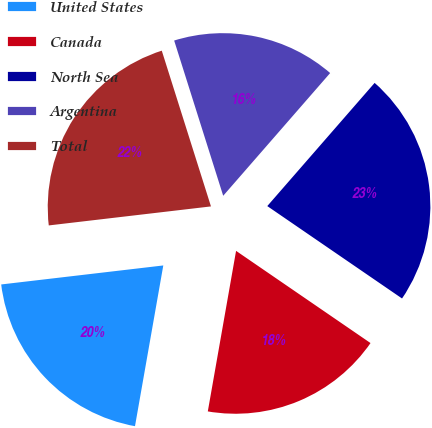<chart> <loc_0><loc_0><loc_500><loc_500><pie_chart><fcel>United States<fcel>Canada<fcel>North Sea<fcel>Argentina<fcel>Total<nl><fcel>20.37%<fcel>18.21%<fcel>23.16%<fcel>16.28%<fcel>21.99%<nl></chart> 